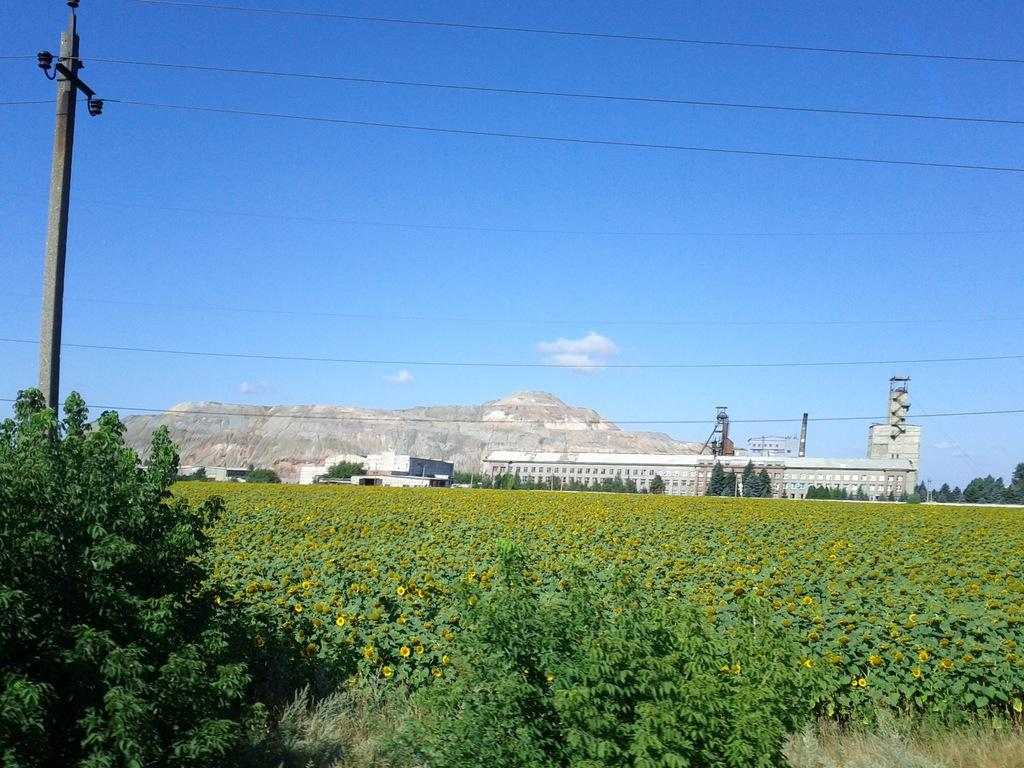What type of living organisms can be seen in the image? Plants can be seen in the image. What man-made structure is present in the image? There is an electric pole in the image. What can be seen in the background of the image? There are buildings, hills, and clouds in the sky in the background of the image. What type of rhythm can be heard coming from the baby in the image? There is no baby present in the image, so it is not possible to determine any rhythm associated with a baby. 